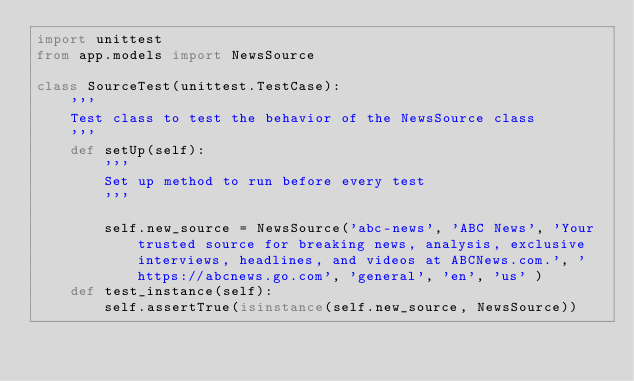Convert code to text. <code><loc_0><loc_0><loc_500><loc_500><_Python_>import unittest
from app.models import NewsSource

class SourceTest(unittest.TestCase):
    '''
    Test class to test the behavior of the NewsSource class
    '''
    def setUp(self):
        '''
        Set up method to run before every test
        '''

        self.new_source = NewsSource('abc-news', 'ABC News', 'Your trusted source for breaking news, analysis, exclusive interviews, headlines, and videos at ABCNews.com.', 'https://abcnews.go.com', 'general', 'en', 'us' )
    def test_instance(self):
        self.assertTrue(isinstance(self.new_source, NewsSource))

</code> 